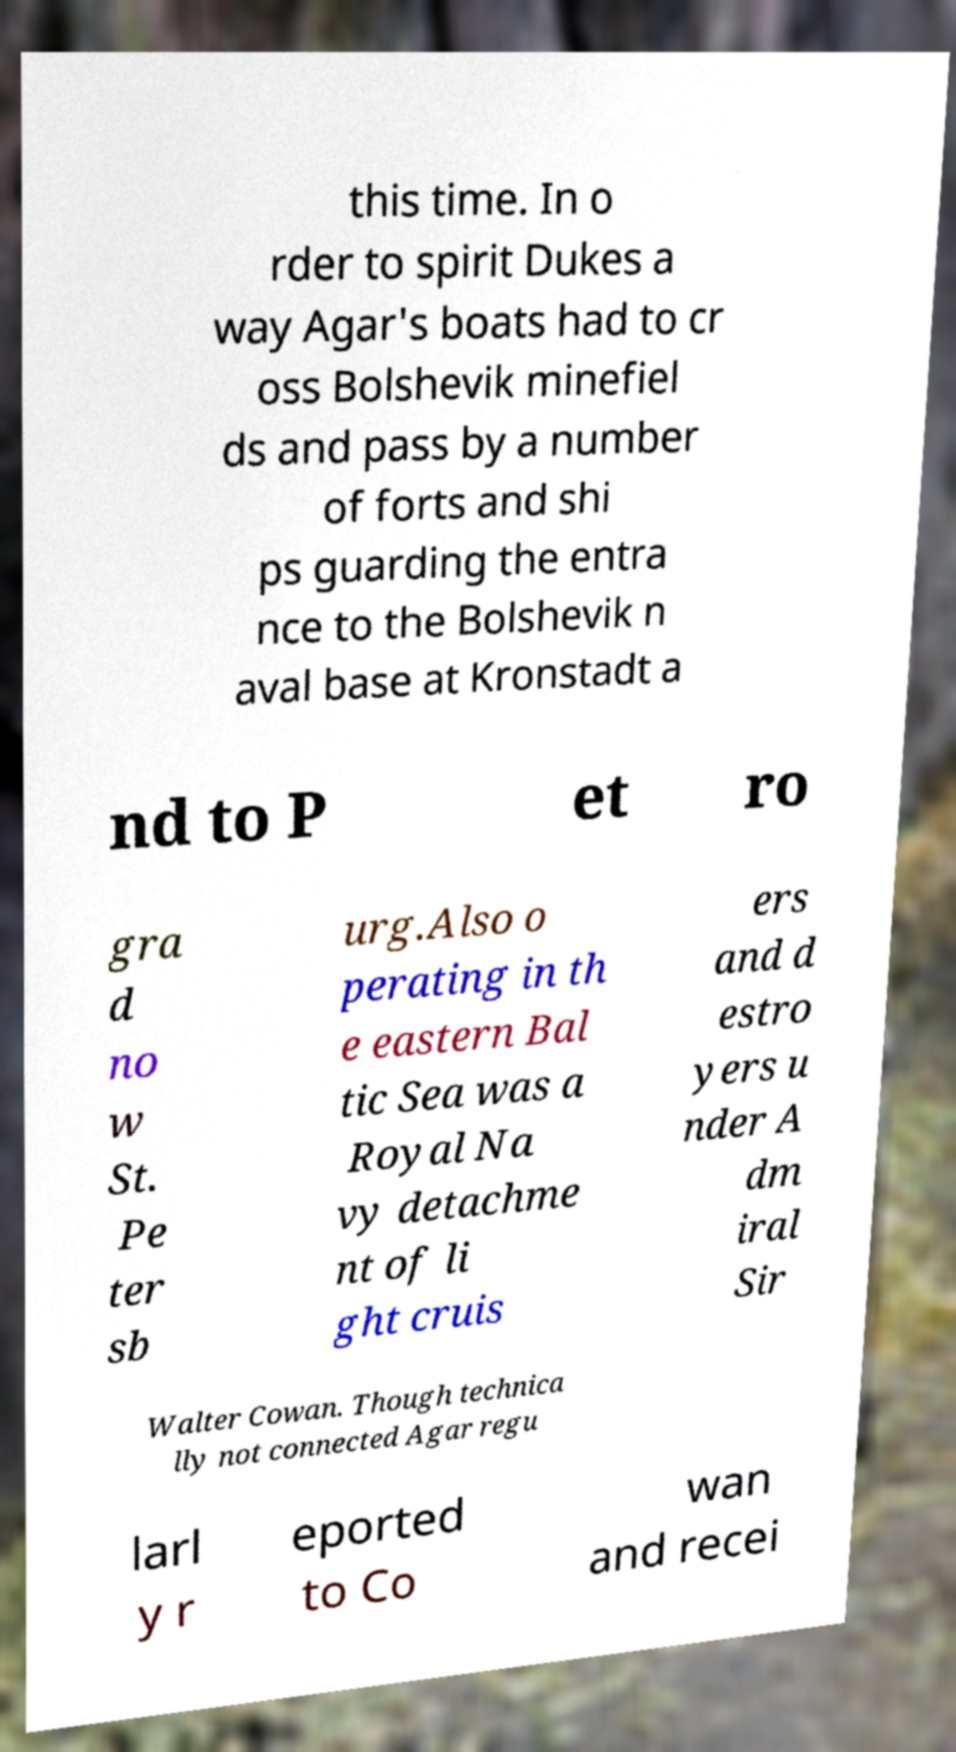Could you extract and type out the text from this image? this time. In o rder to spirit Dukes a way Agar's boats had to cr oss Bolshevik minefiel ds and pass by a number of forts and shi ps guarding the entra nce to the Bolshevik n aval base at Kronstadt a nd to P et ro gra d no w St. Pe ter sb urg.Also o perating in th e eastern Bal tic Sea was a Royal Na vy detachme nt of li ght cruis ers and d estro yers u nder A dm iral Sir Walter Cowan. Though technica lly not connected Agar regu larl y r eported to Co wan and recei 